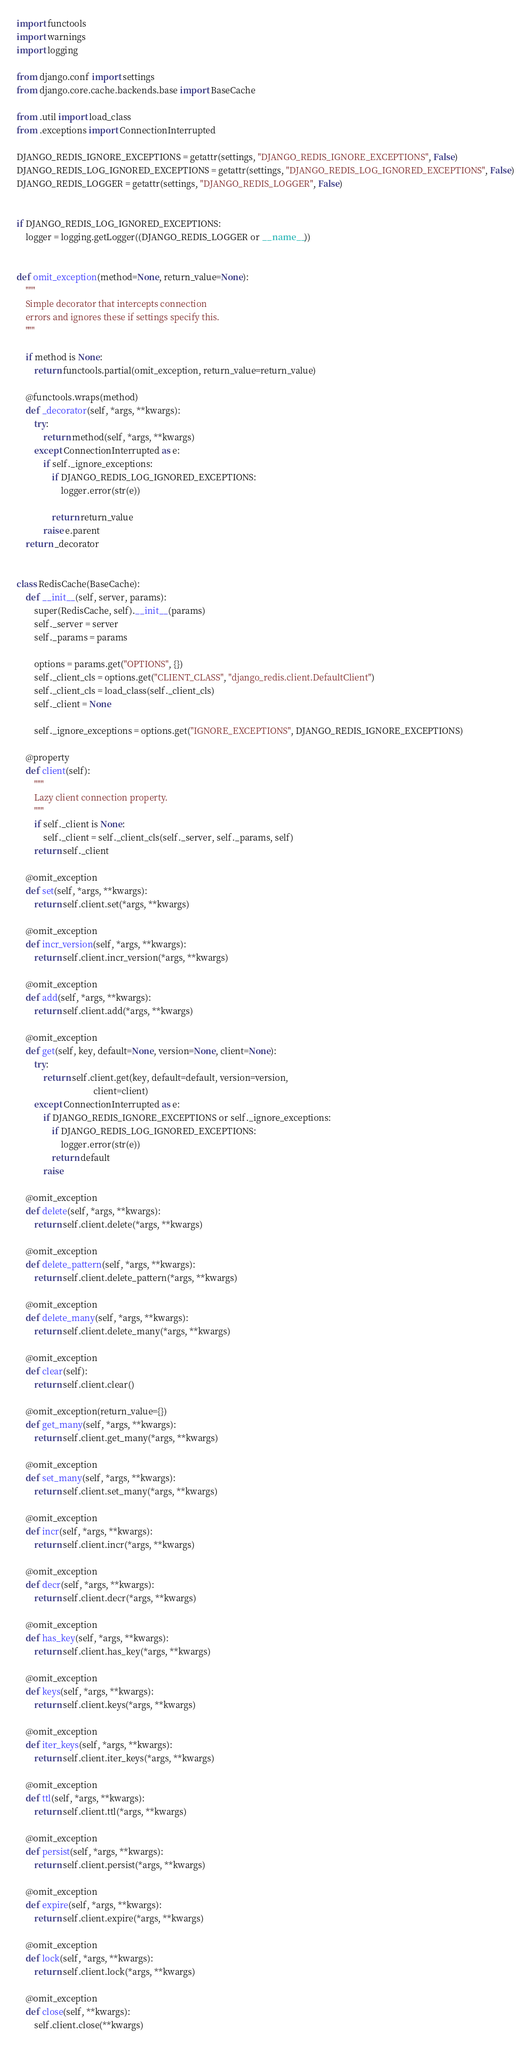<code> <loc_0><loc_0><loc_500><loc_500><_Python_>import functools
import warnings
import logging

from django.conf import settings
from django.core.cache.backends.base import BaseCache

from .util import load_class
from .exceptions import ConnectionInterrupted

DJANGO_REDIS_IGNORE_EXCEPTIONS = getattr(settings, "DJANGO_REDIS_IGNORE_EXCEPTIONS", False)
DJANGO_REDIS_LOG_IGNORED_EXCEPTIONS = getattr(settings, "DJANGO_REDIS_LOG_IGNORED_EXCEPTIONS", False)
DJANGO_REDIS_LOGGER = getattr(settings, "DJANGO_REDIS_LOGGER", False)


if DJANGO_REDIS_LOG_IGNORED_EXCEPTIONS:
    logger = logging.getLogger((DJANGO_REDIS_LOGGER or __name__))


def omit_exception(method=None, return_value=None):
    """
    Simple decorator that intercepts connection
    errors and ignores these if settings specify this.
    """

    if method is None:
        return functools.partial(omit_exception, return_value=return_value)

    @functools.wraps(method)
    def _decorator(self, *args, **kwargs):
        try:
            return method(self, *args, **kwargs)
        except ConnectionInterrupted as e:
            if self._ignore_exceptions:
                if DJANGO_REDIS_LOG_IGNORED_EXCEPTIONS:
                    logger.error(str(e))

                return return_value
            raise e.parent
    return _decorator


class RedisCache(BaseCache):
    def __init__(self, server, params):
        super(RedisCache, self).__init__(params)
        self._server = server
        self._params = params

        options = params.get("OPTIONS", {})
        self._client_cls = options.get("CLIENT_CLASS", "django_redis.client.DefaultClient")
        self._client_cls = load_class(self._client_cls)
        self._client = None

        self._ignore_exceptions = options.get("IGNORE_EXCEPTIONS", DJANGO_REDIS_IGNORE_EXCEPTIONS)

    @property
    def client(self):
        """
        Lazy client connection property.
        """
        if self._client is None:
            self._client = self._client_cls(self._server, self._params, self)
        return self._client

    @omit_exception
    def set(self, *args, **kwargs):
        return self.client.set(*args, **kwargs)

    @omit_exception
    def incr_version(self, *args, **kwargs):
        return self.client.incr_version(*args, **kwargs)

    @omit_exception
    def add(self, *args, **kwargs):
        return self.client.add(*args, **kwargs)

    @omit_exception
    def get(self, key, default=None, version=None, client=None):
        try:
            return self.client.get(key, default=default, version=version,
                                   client=client)
        except ConnectionInterrupted as e:
            if DJANGO_REDIS_IGNORE_EXCEPTIONS or self._ignore_exceptions:
                if DJANGO_REDIS_LOG_IGNORED_EXCEPTIONS:
                    logger.error(str(e))
                return default
            raise

    @omit_exception
    def delete(self, *args, **kwargs):
        return self.client.delete(*args, **kwargs)

    @omit_exception
    def delete_pattern(self, *args, **kwargs):
        return self.client.delete_pattern(*args, **kwargs)

    @omit_exception
    def delete_many(self, *args, **kwargs):
        return self.client.delete_many(*args, **kwargs)

    @omit_exception
    def clear(self):
        return self.client.clear()

    @omit_exception(return_value={})
    def get_many(self, *args, **kwargs):
        return self.client.get_many(*args, **kwargs)

    @omit_exception
    def set_many(self, *args, **kwargs):
        return self.client.set_many(*args, **kwargs)

    @omit_exception
    def incr(self, *args, **kwargs):
        return self.client.incr(*args, **kwargs)

    @omit_exception
    def decr(self, *args, **kwargs):
        return self.client.decr(*args, **kwargs)

    @omit_exception
    def has_key(self, *args, **kwargs):
        return self.client.has_key(*args, **kwargs)

    @omit_exception
    def keys(self, *args, **kwargs):
        return self.client.keys(*args, **kwargs)

    @omit_exception
    def iter_keys(self, *args, **kwargs):
        return self.client.iter_keys(*args, **kwargs)

    @omit_exception
    def ttl(self, *args, **kwargs):
        return self.client.ttl(*args, **kwargs)

    @omit_exception
    def persist(self, *args, **kwargs):
        return self.client.persist(*args, **kwargs)

    @omit_exception
    def expire(self, *args, **kwargs):
        return self.client.expire(*args, **kwargs)

    @omit_exception
    def lock(self, *args, **kwargs):
        return self.client.lock(*args, **kwargs)

    @omit_exception
    def close(self, **kwargs):
        self.client.close(**kwargs)
</code> 